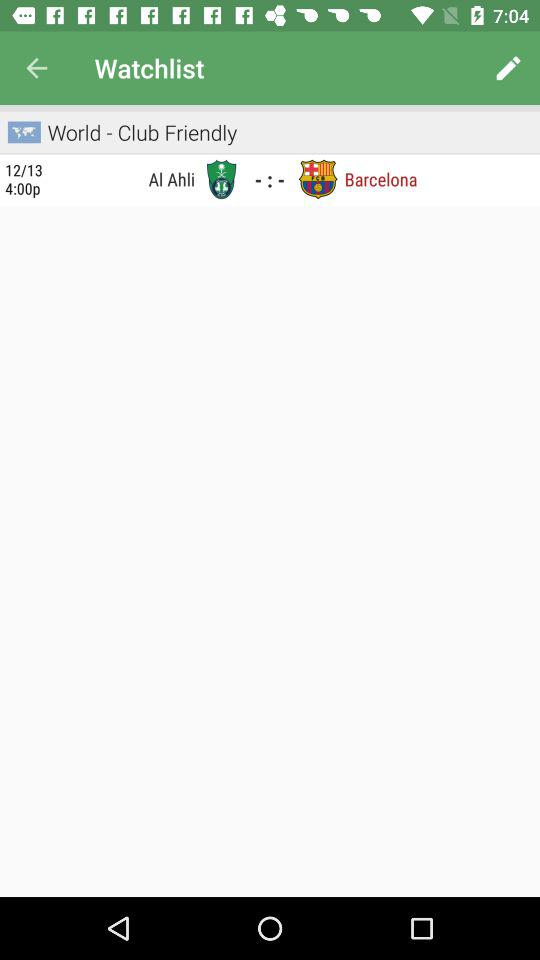What is the given date? The given date is December 13. 